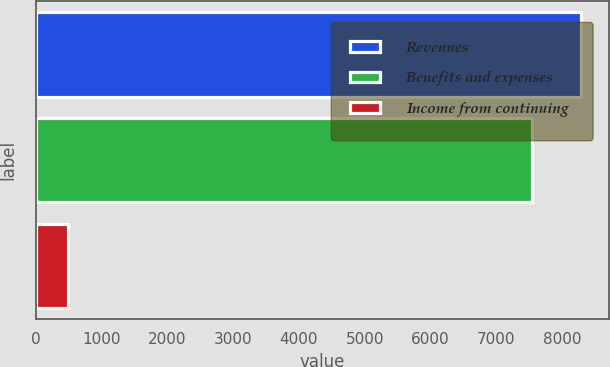Convert chart to OTSL. <chart><loc_0><loc_0><loc_500><loc_500><bar_chart><fcel>Revenues<fcel>Benefits and expenses<fcel>Income from continuing<nl><fcel>8298.4<fcel>7544<fcel>482<nl></chart> 